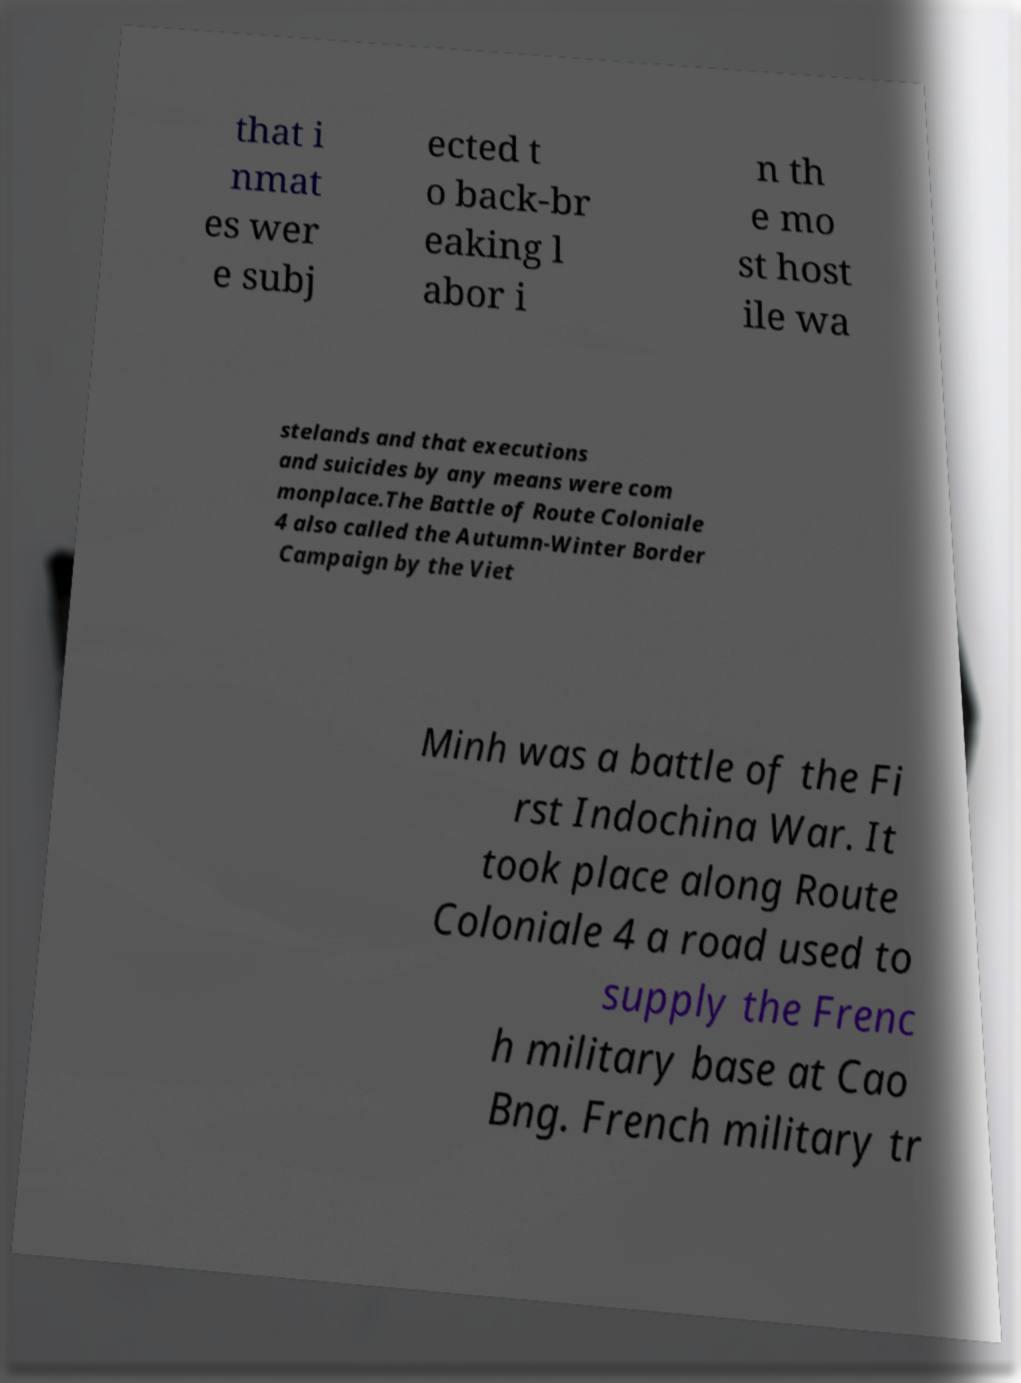Can you read and provide the text displayed in the image?This photo seems to have some interesting text. Can you extract and type it out for me? that i nmat es wer e subj ected t o back-br eaking l abor i n th e mo st host ile wa stelands and that executions and suicides by any means were com monplace.The Battle of Route Coloniale 4 also called the Autumn-Winter Border Campaign by the Viet Minh was a battle of the Fi rst Indochina War. It took place along Route Coloniale 4 a road used to supply the Frenc h military base at Cao Bng. French military tr 